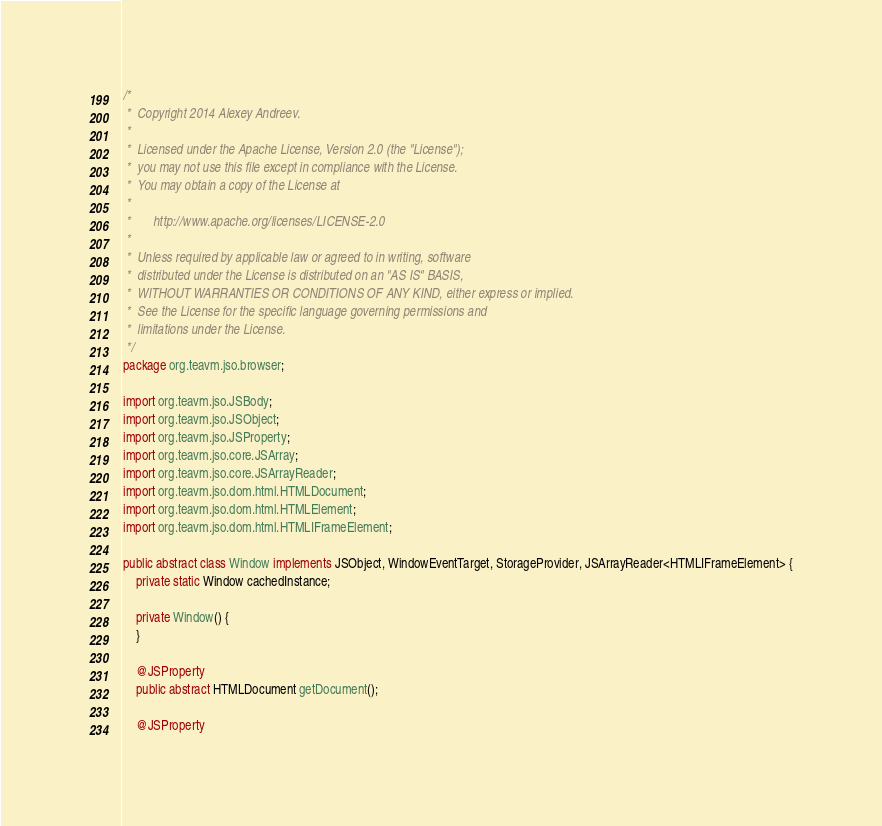<code> <loc_0><loc_0><loc_500><loc_500><_Java_>/*
 *  Copyright 2014 Alexey Andreev.
 *
 *  Licensed under the Apache License, Version 2.0 (the "License");
 *  you may not use this file except in compliance with the License.
 *  You may obtain a copy of the License at
 *
 *       http://www.apache.org/licenses/LICENSE-2.0
 *
 *  Unless required by applicable law or agreed to in writing, software
 *  distributed under the License is distributed on an "AS IS" BASIS,
 *  WITHOUT WARRANTIES OR CONDITIONS OF ANY KIND, either express or implied.
 *  See the License for the specific language governing permissions and
 *  limitations under the License.
 */
package org.teavm.jso.browser;

import org.teavm.jso.JSBody;
import org.teavm.jso.JSObject;
import org.teavm.jso.JSProperty;
import org.teavm.jso.core.JSArray;
import org.teavm.jso.core.JSArrayReader;
import org.teavm.jso.dom.html.HTMLDocument;
import org.teavm.jso.dom.html.HTMLElement;
import org.teavm.jso.dom.html.HTMLIFrameElement;

public abstract class Window implements JSObject, WindowEventTarget, StorageProvider, JSArrayReader<HTMLIFrameElement> {
    private static Window cachedInstance;

    private Window() {
    }

    @JSProperty
    public abstract HTMLDocument getDocument();

    @JSProperty</code> 